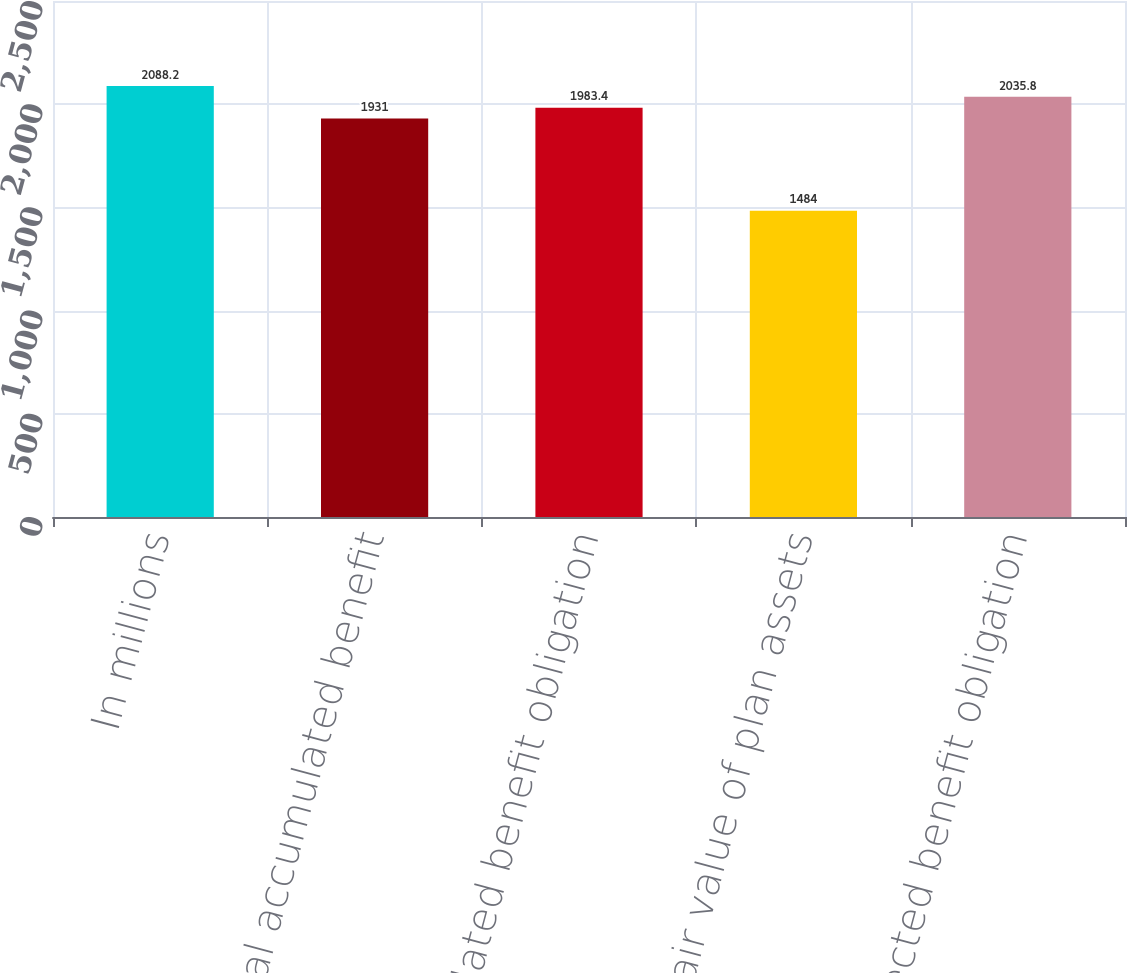<chart> <loc_0><loc_0><loc_500><loc_500><bar_chart><fcel>In millions<fcel>Total accumulated benefit<fcel>Accumulated benefit obligation<fcel>Fair value of plan assets<fcel>Projected benefit obligation<nl><fcel>2088.2<fcel>1931<fcel>1983.4<fcel>1484<fcel>2035.8<nl></chart> 